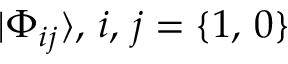<formula> <loc_0><loc_0><loc_500><loc_500>| \Phi _ { i j } \rangle , \, i , \, j = \{ 1 , \, 0 \}</formula> 